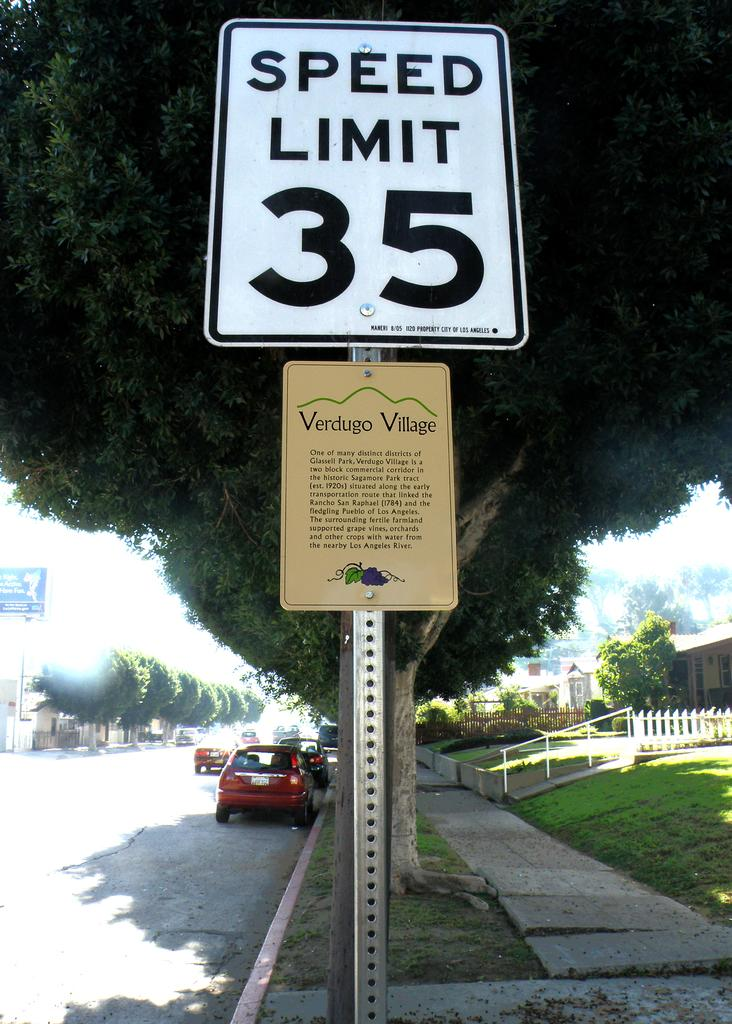<image>
Relay a brief, clear account of the picture shown. The speed limit on this street is 35 miles per hour. 